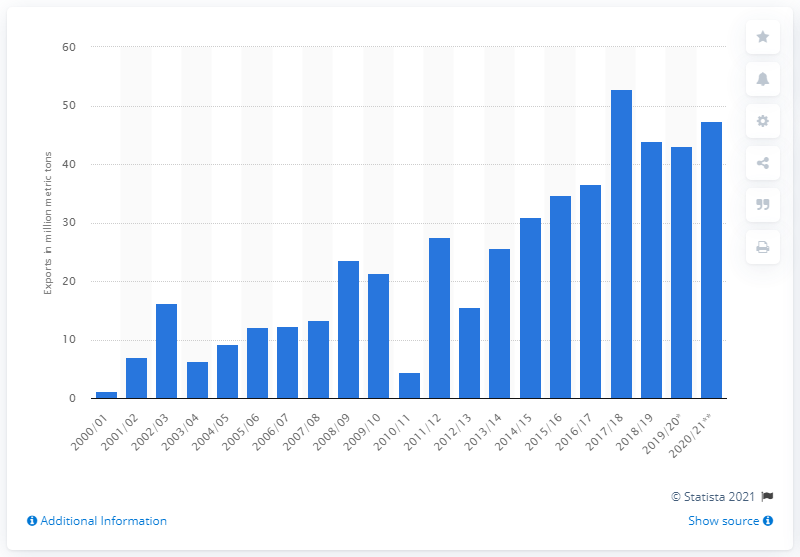Give some essential details in this illustration. According to forecasts, Russia was expected to export 47.43 metric tons of cereals in crop year 2020/2021. In 2020/2021, Russia's cereal exports were 47.43% higher than the previous period, indicating a significant increase in the country's agricultural exports. 